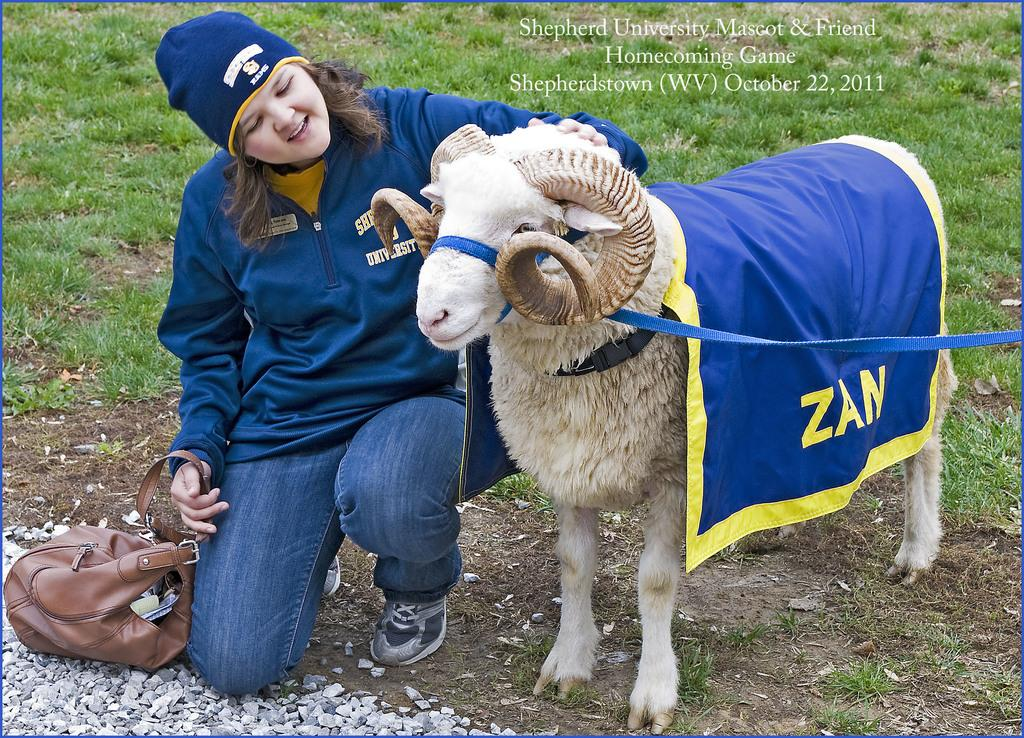Who is present in the image? There is a woman in the image. What is the woman holding in the image? The woman is holding a bag. What type of animal can be seen in the image? There is a sheep in the image. What type of vegetation is visible in the image? There is grass visible in the image. What channel is the woman watching on the stage in the image? There is no channel or stage present in the image; it features a woman holding a bag and a sheep in a grassy area. 